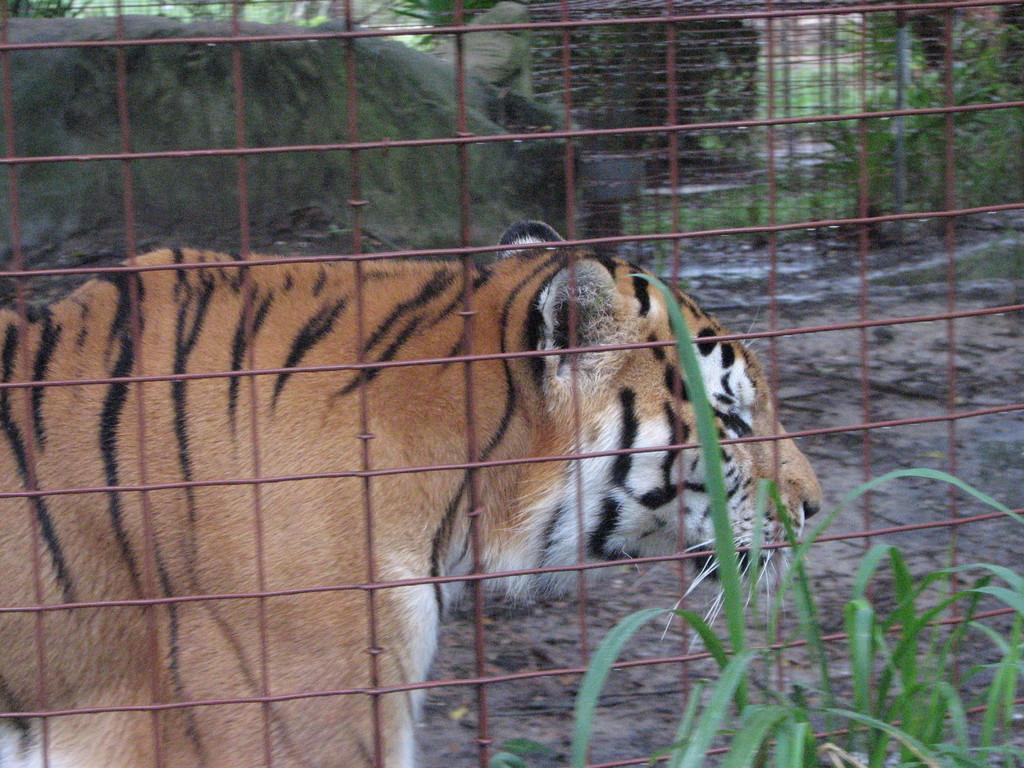Could you give a brief overview of what you see in this image? Here we can see a plant. Backside of this mesh there is a tiger and plants. 